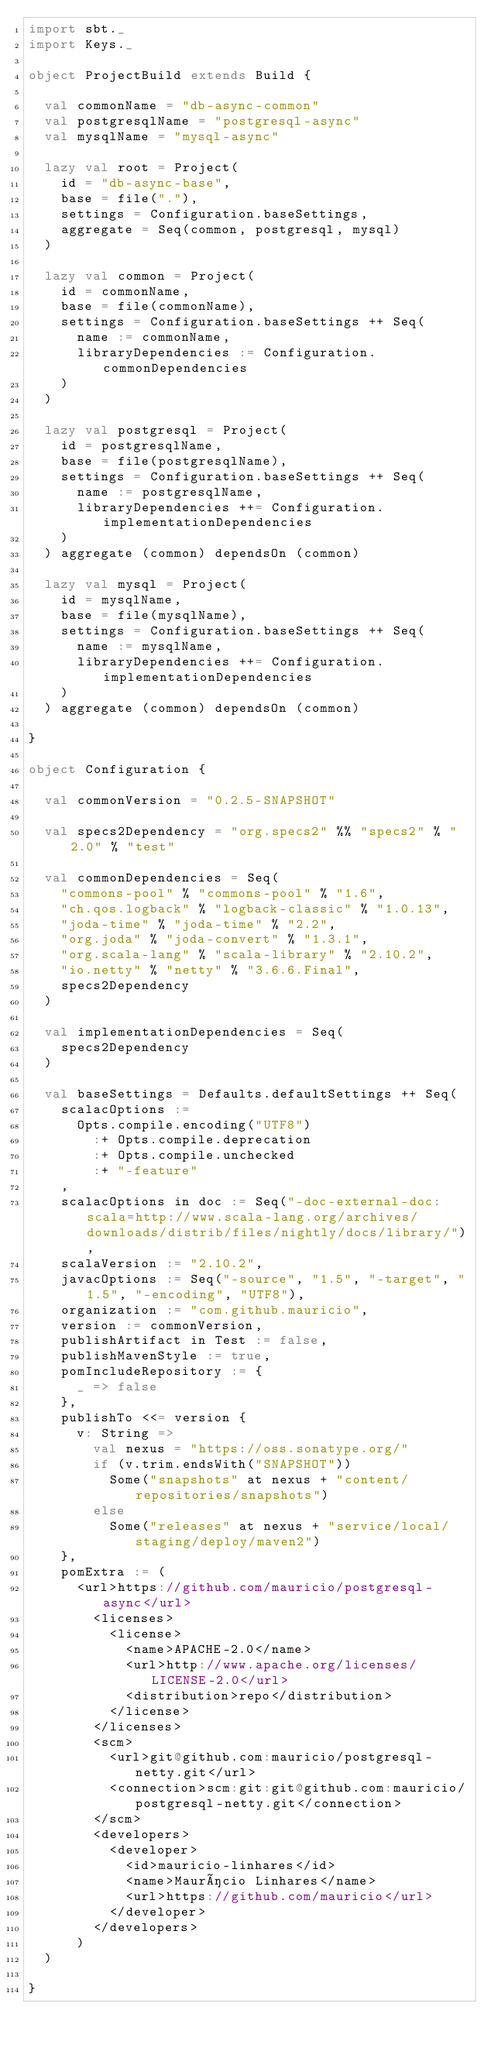<code> <loc_0><loc_0><loc_500><loc_500><_Scala_>import sbt._
import Keys._

object ProjectBuild extends Build {

  val commonName = "db-async-common"
  val postgresqlName = "postgresql-async"
  val mysqlName = "mysql-async"

  lazy val root = Project(
    id = "db-async-base",
    base = file("."),
    settings = Configuration.baseSettings,
    aggregate = Seq(common, postgresql, mysql)
  )

  lazy val common = Project(
    id = commonName,
    base = file(commonName),
    settings = Configuration.baseSettings ++ Seq(
      name := commonName,
      libraryDependencies := Configuration.commonDependencies
    )
  )

  lazy val postgresql = Project(
    id = postgresqlName,
    base = file(postgresqlName),
    settings = Configuration.baseSettings ++ Seq(
      name := postgresqlName,
      libraryDependencies ++= Configuration.implementationDependencies
    )
  ) aggregate (common) dependsOn (common)

  lazy val mysql = Project(
    id = mysqlName,
    base = file(mysqlName),
    settings = Configuration.baseSettings ++ Seq(
      name := mysqlName,
      libraryDependencies ++= Configuration.implementationDependencies
    )
  ) aggregate (common) dependsOn (common)

}

object Configuration {

  val commonVersion = "0.2.5-SNAPSHOT"

  val specs2Dependency = "org.specs2" %% "specs2" % "2.0" % "test"

  val commonDependencies = Seq(
    "commons-pool" % "commons-pool" % "1.6",
    "ch.qos.logback" % "logback-classic" % "1.0.13",
    "joda-time" % "joda-time" % "2.2",
    "org.joda" % "joda-convert" % "1.3.1",
    "org.scala-lang" % "scala-library" % "2.10.2",
    "io.netty" % "netty" % "3.6.6.Final",
    specs2Dependency
  )

  val implementationDependencies = Seq(
    specs2Dependency
  )

  val baseSettings = Defaults.defaultSettings ++ Seq(
    scalacOptions :=
      Opts.compile.encoding("UTF8")
        :+ Opts.compile.deprecation
        :+ Opts.compile.unchecked
        :+ "-feature"
    ,
    scalacOptions in doc := Seq("-doc-external-doc:scala=http://www.scala-lang.org/archives/downloads/distrib/files/nightly/docs/library/"),
    scalaVersion := "2.10.2",
    javacOptions := Seq("-source", "1.5", "-target", "1.5", "-encoding", "UTF8"),
    organization := "com.github.mauricio",
    version := commonVersion,
    publishArtifact in Test := false,
    publishMavenStyle := true,
    pomIncludeRepository := {
      _ => false
    },
    publishTo <<= version {
      v: String =>
        val nexus = "https://oss.sonatype.org/"
        if (v.trim.endsWith("SNAPSHOT"))
          Some("snapshots" at nexus + "content/repositories/snapshots")
        else
          Some("releases" at nexus + "service/local/staging/deploy/maven2")
    },
    pomExtra := (
      <url>https://github.com/mauricio/postgresql-async</url>
        <licenses>
          <license>
            <name>APACHE-2.0</name>
            <url>http://www.apache.org/licenses/LICENSE-2.0</url>
            <distribution>repo</distribution>
          </license>
        </licenses>
        <scm>
          <url>git@github.com:mauricio/postgresql-netty.git</url>
          <connection>scm:git:git@github.com:mauricio/postgresql-netty.git</connection>
        </scm>
        <developers>
          <developer>
            <id>mauricio-linhares</id>
            <name>Maurício Linhares</name>
            <url>https://github.com/mauricio</url>
          </developer>
        </developers>
      )
  )

}</code> 